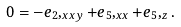Convert formula to latex. <formula><loc_0><loc_0><loc_500><loc_500>0 = - e _ { 2 } , _ { x x y } + e _ { 5 } , _ { x x } + e _ { 5 } , _ { z } .</formula> 